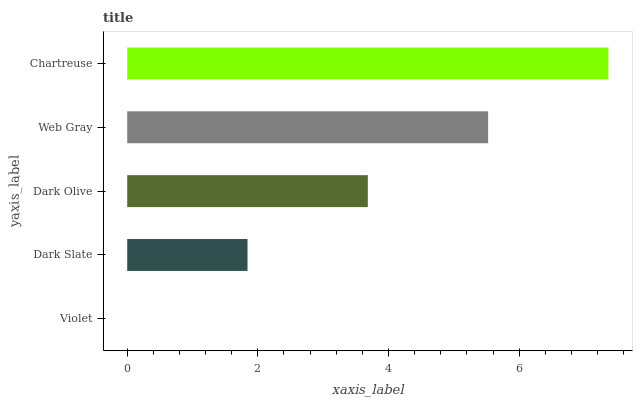Is Violet the minimum?
Answer yes or no. Yes. Is Chartreuse the maximum?
Answer yes or no. Yes. Is Dark Slate the minimum?
Answer yes or no. No. Is Dark Slate the maximum?
Answer yes or no. No. Is Dark Slate greater than Violet?
Answer yes or no. Yes. Is Violet less than Dark Slate?
Answer yes or no. Yes. Is Violet greater than Dark Slate?
Answer yes or no. No. Is Dark Slate less than Violet?
Answer yes or no. No. Is Dark Olive the high median?
Answer yes or no. Yes. Is Dark Olive the low median?
Answer yes or no. Yes. Is Violet the high median?
Answer yes or no. No. Is Web Gray the low median?
Answer yes or no. No. 